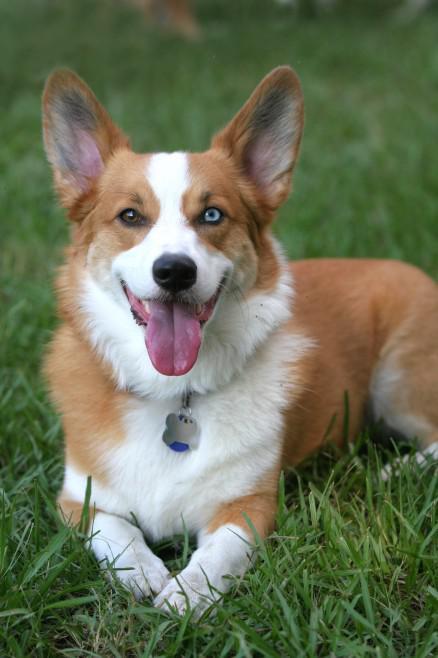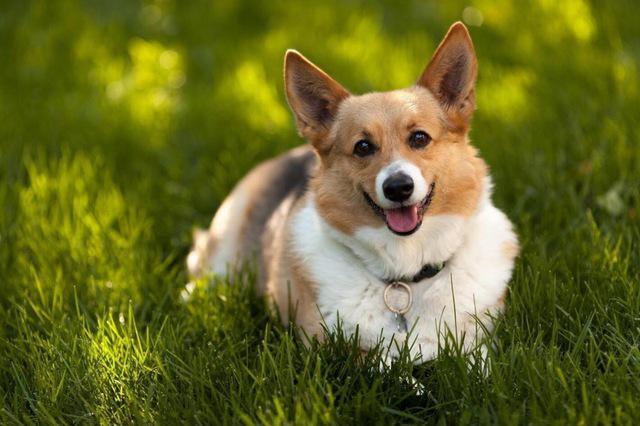The first image is the image on the left, the second image is the image on the right. Assess this claim about the two images: "Each image contains one orange-and-white corgi dog, each of the depicted dogs has its face turned forward.". Correct or not? Answer yes or no. Yes. The first image is the image on the left, the second image is the image on the right. Assess this claim about the two images: "The dog in the left image has its tongue out.". Correct or not? Answer yes or no. Yes. 